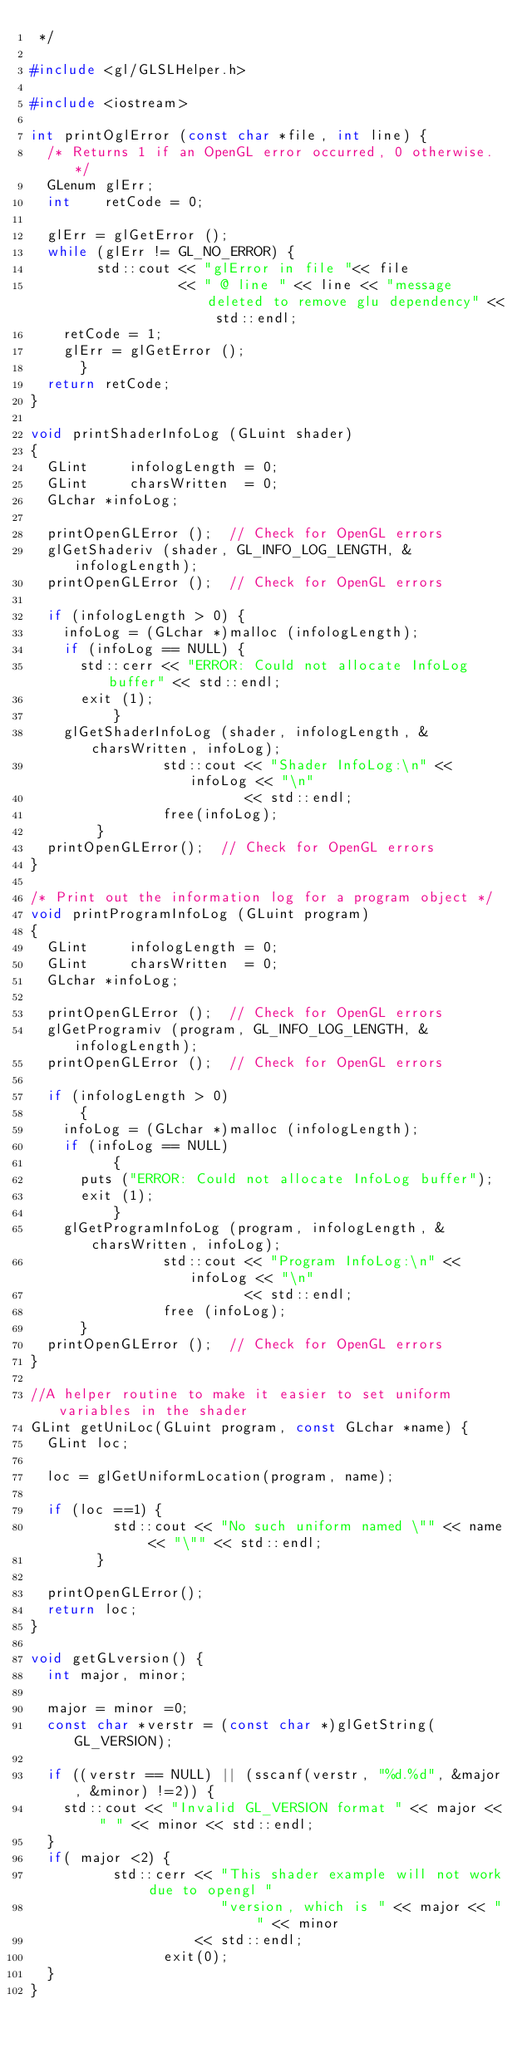Convert code to text. <code><loc_0><loc_0><loc_500><loc_500><_C++_> */

#include <gl/GLSLHelper.h>

#include <iostream>

int printOglError (const char *file, int line) {
	/* Returns 1 if an OpenGL error occurred, 0 otherwise. */
	GLenum glErr;
	int    retCode = 0;
	
	glErr = glGetError ();
	while (glErr != GL_NO_ERROR) {
        std::cout << "glError in file "<< file 
                  << " @ line " << line << "message deleted to remove glu dependency" << std::endl;
		retCode = 1;
		glErr = glGetError ();
    	}
	return retCode;
}

void printShaderInfoLog (GLuint shader)
{
	GLint     infologLength = 0;
	GLint     charsWritten  = 0;
	GLchar *infoLog;
	
	printOpenGLError ();  // Check for OpenGL errors
	glGetShaderiv (shader, GL_INFO_LOG_LENGTH, &infologLength);
	printOpenGLError ();  // Check for OpenGL errors
	
	if (infologLength > 0) {
		infoLog = (GLchar *)malloc (infologLength);
		if (infoLog == NULL) {
			std::cerr << "ERROR: Could not allocate InfoLog buffer" << std::endl;
			exit (1);
        	}
		glGetShaderInfoLog (shader, infologLength, &charsWritten, infoLog);
                std::cout << "Shader InfoLog:\n" << infoLog << "\n"
                          << std::endl;
                free(infoLog);
        }
	printOpenGLError();  // Check for OpenGL errors
}

/* Print out the information log for a program object */
void printProgramInfoLog (GLuint program)
{
	GLint     infologLength = 0;
	GLint     charsWritten  = 0;
	GLchar *infoLog;
	
	printOpenGLError ();  // Check for OpenGL errors
	glGetProgramiv (program, GL_INFO_LOG_LENGTH, &infologLength);
	printOpenGLError ();  // Check for OpenGL errors
	
	if (infologLength > 0)
    	{
		infoLog = (GLchar *)malloc (infologLength);
		if (infoLog == NULL)
        	{
			puts ("ERROR: Could not allocate InfoLog buffer");
			exit (1);
        	}
		glGetProgramInfoLog (program, infologLength, &charsWritten, infoLog);
                std::cout << "Program InfoLog:\n" << infoLog << "\n"
                          << std::endl;
                free (infoLog);
    	}
	printOpenGLError ();  // Check for OpenGL errors
}

//A helper routine to make it easier to set uniform variables in the shader
GLint getUniLoc(GLuint program, const GLchar *name) {
	GLint loc;
	
	loc = glGetUniformLocation(program, name);
	
	if (loc ==1) {
          std::cout << "No such uniform named \"" << name << "\"" << std::endl;
        }
	
	printOpenGLError();
	return loc;
}

void getGLversion() {
	int major, minor;
	
	major = minor =0;
	const char *verstr = (const char *)glGetString(GL_VERSION);
	
	if ((verstr == NULL) || (sscanf(verstr, "%d.%d", &major, &minor) !=2)) {
		std::cout << "Invalid GL_VERSION format " << major << " " << minor << std::endl;
	}
	if( major <2) {
          std::cerr << "This shader example will not work due to opengl "
                       "version, which is " << major << " " << minor
                    << std::endl;
                exit(0);
	}
}
</code> 